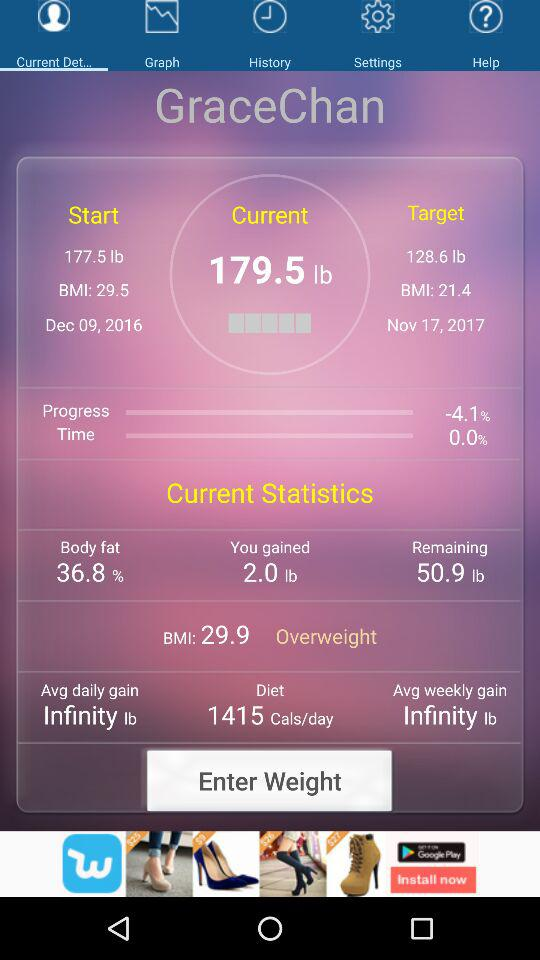How much weight loss is shown in the graph?
When the provided information is insufficient, respond with <no answer>. <no answer> 